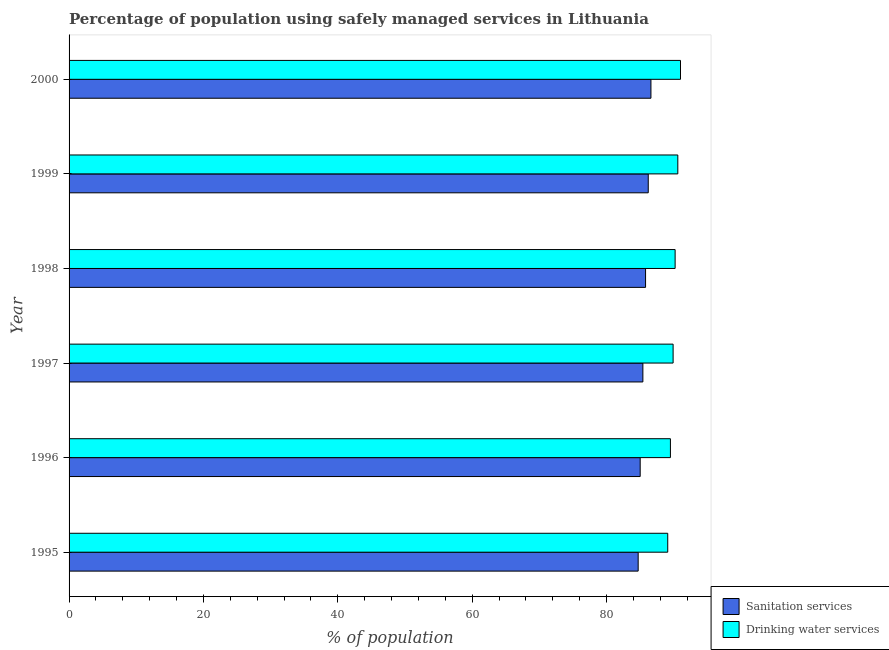How many different coloured bars are there?
Make the answer very short. 2. How many groups of bars are there?
Keep it short and to the point. 6. Are the number of bars per tick equal to the number of legend labels?
Your response must be concise. Yes. How many bars are there on the 4th tick from the top?
Your answer should be compact. 2. In how many cases, is the number of bars for a given year not equal to the number of legend labels?
Keep it short and to the point. 0. What is the percentage of population who used sanitation services in 1997?
Keep it short and to the point. 85.4. Across all years, what is the maximum percentage of population who used sanitation services?
Make the answer very short. 86.6. Across all years, what is the minimum percentage of population who used drinking water services?
Provide a succinct answer. 89.1. In which year was the percentage of population who used sanitation services maximum?
Your answer should be compact. 2000. What is the total percentage of population who used sanitation services in the graph?
Offer a very short reply. 513.7. What is the difference between the percentage of population who used drinking water services in 1999 and the percentage of population who used sanitation services in 2000?
Ensure brevity in your answer.  4. What is the average percentage of population who used sanitation services per year?
Offer a very short reply. 85.62. In the year 1996, what is the difference between the percentage of population who used sanitation services and percentage of population who used drinking water services?
Give a very brief answer. -4.5. In how many years, is the percentage of population who used drinking water services greater than 20 %?
Your response must be concise. 6. Is the percentage of population who used drinking water services in 1995 less than that in 1999?
Make the answer very short. Yes. What does the 1st bar from the top in 1999 represents?
Your response must be concise. Drinking water services. What does the 1st bar from the bottom in 1995 represents?
Ensure brevity in your answer.  Sanitation services. How many bars are there?
Your response must be concise. 12. How many years are there in the graph?
Provide a short and direct response. 6. What is the difference between two consecutive major ticks on the X-axis?
Your response must be concise. 20. Are the values on the major ticks of X-axis written in scientific E-notation?
Make the answer very short. No. Does the graph contain grids?
Offer a very short reply. No. Where does the legend appear in the graph?
Offer a very short reply. Bottom right. How are the legend labels stacked?
Offer a terse response. Vertical. What is the title of the graph?
Your response must be concise. Percentage of population using safely managed services in Lithuania. What is the label or title of the X-axis?
Make the answer very short. % of population. What is the % of population in Sanitation services in 1995?
Ensure brevity in your answer.  84.7. What is the % of population in Drinking water services in 1995?
Your answer should be compact. 89.1. What is the % of population of Sanitation services in 1996?
Give a very brief answer. 85. What is the % of population in Drinking water services in 1996?
Offer a very short reply. 89.5. What is the % of population of Sanitation services in 1997?
Keep it short and to the point. 85.4. What is the % of population of Drinking water services in 1997?
Offer a terse response. 89.9. What is the % of population in Sanitation services in 1998?
Provide a short and direct response. 85.8. What is the % of population of Drinking water services in 1998?
Provide a succinct answer. 90.2. What is the % of population in Sanitation services in 1999?
Ensure brevity in your answer.  86.2. What is the % of population of Drinking water services in 1999?
Make the answer very short. 90.6. What is the % of population in Sanitation services in 2000?
Ensure brevity in your answer.  86.6. What is the % of population in Drinking water services in 2000?
Keep it short and to the point. 91. Across all years, what is the maximum % of population of Sanitation services?
Provide a succinct answer. 86.6. Across all years, what is the maximum % of population in Drinking water services?
Offer a terse response. 91. Across all years, what is the minimum % of population in Sanitation services?
Make the answer very short. 84.7. Across all years, what is the minimum % of population in Drinking water services?
Offer a terse response. 89.1. What is the total % of population of Sanitation services in the graph?
Your answer should be compact. 513.7. What is the total % of population in Drinking water services in the graph?
Offer a terse response. 540.3. What is the difference between the % of population in Sanitation services in 1995 and that in 1996?
Make the answer very short. -0.3. What is the difference between the % of population in Drinking water services in 1995 and that in 1996?
Offer a terse response. -0.4. What is the difference between the % of population of Sanitation services in 1995 and that in 1997?
Offer a terse response. -0.7. What is the difference between the % of population of Drinking water services in 1995 and that in 1997?
Give a very brief answer. -0.8. What is the difference between the % of population in Sanitation services in 1995 and that in 1999?
Ensure brevity in your answer.  -1.5. What is the difference between the % of population in Sanitation services in 1995 and that in 2000?
Provide a succinct answer. -1.9. What is the difference between the % of population in Drinking water services in 1996 and that in 1997?
Keep it short and to the point. -0.4. What is the difference between the % of population in Drinking water services in 1996 and that in 1999?
Offer a terse response. -1.1. What is the difference between the % of population of Sanitation services in 1996 and that in 2000?
Your response must be concise. -1.6. What is the difference between the % of population of Sanitation services in 1997 and that in 1998?
Ensure brevity in your answer.  -0.4. What is the difference between the % of population in Drinking water services in 1997 and that in 1998?
Offer a terse response. -0.3. What is the difference between the % of population of Sanitation services in 1997 and that in 1999?
Your answer should be very brief. -0.8. What is the difference between the % of population in Sanitation services in 1998 and that in 2000?
Ensure brevity in your answer.  -0.8. What is the difference between the % of population of Drinking water services in 1998 and that in 2000?
Provide a succinct answer. -0.8. What is the difference between the % of population of Drinking water services in 1999 and that in 2000?
Your answer should be compact. -0.4. What is the difference between the % of population of Sanitation services in 1995 and the % of population of Drinking water services in 1997?
Your response must be concise. -5.2. What is the difference between the % of population in Sanitation services in 1995 and the % of population in Drinking water services in 1999?
Ensure brevity in your answer.  -5.9. What is the difference between the % of population of Sanitation services in 1996 and the % of population of Drinking water services in 1997?
Keep it short and to the point. -4.9. What is the difference between the % of population of Sanitation services in 1996 and the % of population of Drinking water services in 1998?
Your answer should be compact. -5.2. What is the difference between the % of population in Sanitation services in 1996 and the % of population in Drinking water services in 1999?
Offer a terse response. -5.6. What is the difference between the % of population in Sanitation services in 1996 and the % of population in Drinking water services in 2000?
Offer a terse response. -6. What is the difference between the % of population of Sanitation services in 1997 and the % of population of Drinking water services in 1999?
Your answer should be very brief. -5.2. What is the difference between the % of population in Sanitation services in 1997 and the % of population in Drinking water services in 2000?
Offer a very short reply. -5.6. What is the difference between the % of population in Sanitation services in 1998 and the % of population in Drinking water services in 1999?
Ensure brevity in your answer.  -4.8. What is the average % of population of Sanitation services per year?
Your answer should be compact. 85.62. What is the average % of population of Drinking water services per year?
Your response must be concise. 90.05. In the year 1995, what is the difference between the % of population of Sanitation services and % of population of Drinking water services?
Provide a short and direct response. -4.4. In the year 1998, what is the difference between the % of population in Sanitation services and % of population in Drinking water services?
Your response must be concise. -4.4. What is the ratio of the % of population of Sanitation services in 1995 to that in 1996?
Offer a terse response. 1. What is the ratio of the % of population in Sanitation services in 1995 to that in 1997?
Offer a very short reply. 0.99. What is the ratio of the % of population in Sanitation services in 1995 to that in 1998?
Make the answer very short. 0.99. What is the ratio of the % of population of Drinking water services in 1995 to that in 1998?
Your answer should be compact. 0.99. What is the ratio of the % of population of Sanitation services in 1995 to that in 1999?
Ensure brevity in your answer.  0.98. What is the ratio of the % of population of Drinking water services in 1995 to that in 1999?
Offer a terse response. 0.98. What is the ratio of the % of population of Sanitation services in 1995 to that in 2000?
Ensure brevity in your answer.  0.98. What is the ratio of the % of population of Drinking water services in 1995 to that in 2000?
Provide a succinct answer. 0.98. What is the ratio of the % of population in Drinking water services in 1996 to that in 1997?
Ensure brevity in your answer.  1. What is the ratio of the % of population of Drinking water services in 1996 to that in 1998?
Your response must be concise. 0.99. What is the ratio of the % of population in Sanitation services in 1996 to that in 1999?
Your answer should be compact. 0.99. What is the ratio of the % of population of Drinking water services in 1996 to that in 1999?
Your answer should be very brief. 0.99. What is the ratio of the % of population in Sanitation services in 1996 to that in 2000?
Give a very brief answer. 0.98. What is the ratio of the % of population of Drinking water services in 1996 to that in 2000?
Provide a succinct answer. 0.98. What is the ratio of the % of population of Drinking water services in 1997 to that in 1998?
Keep it short and to the point. 1. What is the ratio of the % of population in Drinking water services in 1997 to that in 1999?
Make the answer very short. 0.99. What is the ratio of the % of population of Sanitation services in 1997 to that in 2000?
Your answer should be very brief. 0.99. What is the ratio of the % of population in Drinking water services in 1997 to that in 2000?
Keep it short and to the point. 0.99. What is the ratio of the % of population of Drinking water services in 1998 to that in 2000?
Provide a succinct answer. 0.99. What is the difference between the highest and the second highest % of population in Sanitation services?
Keep it short and to the point. 0.4. What is the difference between the highest and the second highest % of population of Drinking water services?
Provide a succinct answer. 0.4. What is the difference between the highest and the lowest % of population in Sanitation services?
Keep it short and to the point. 1.9. 